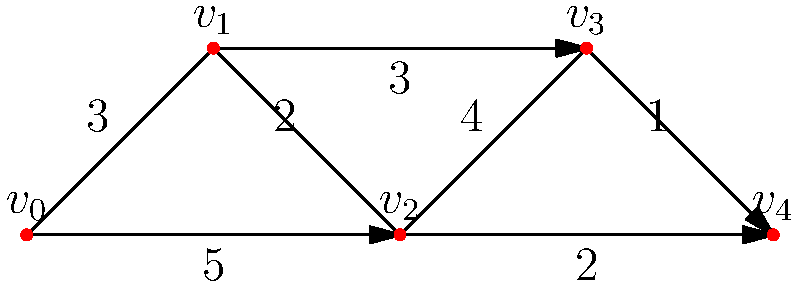You're designing an irrigation system for your permaculture farm. The graph represents possible water flow paths between different garden sections (vertices). Edge weights indicate water usage in liters per minute. What's the minimum amount of water needed to irrigate all sections while ensuring water flows from the source ($v_0$) to every other section? To solve this problem, we need to find the minimum spanning tree (MST) of the graph, which will give us the most efficient irrigation system design. We'll use Kruskal's algorithm:

1. Sort edges by weight in ascending order:
   $(v_3, v_4): 1$
   $(v_2, v_4): 2$
   $(v_1, v_2): 2$
   $(v_0, v_1): 3$
   $(v_1, v_3): 3$
   $(v_2, v_3): 4$
   $(v_0, v_2): 5$

2. Start with an empty set of edges and add edges that don't create cycles:
   - Add $(v_3, v_4): 1$
   - Add $(v_2, v_4): 2$
   - Add $(v_1, v_2): 2$
   - Add $(v_0, v_1): 3$

3. The MST is now complete, connecting all vertices.

4. Calculate total water usage:
   $1 + 2 + 2 + 3 = 8$ liters per minute

Therefore, the minimum amount of water needed to irrigate all sections is 8 liters per minute.
Answer: 8 liters per minute 